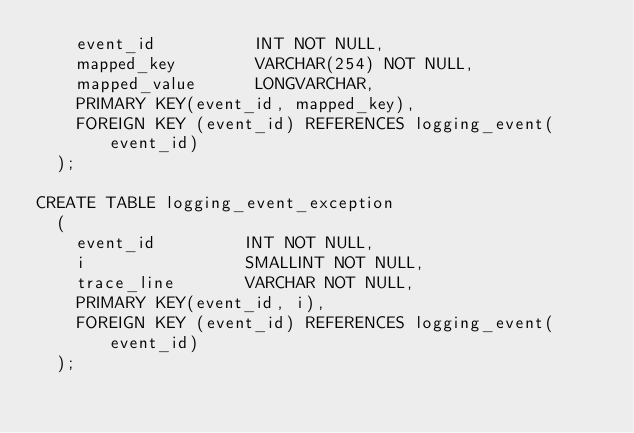<code> <loc_0><loc_0><loc_500><loc_500><_SQL_>    event_id	      INT NOT NULL,
    mapped_key        VARCHAR(254) NOT NULL,
    mapped_value      LONGVARCHAR,
    PRIMARY KEY(event_id, mapped_key),
    FOREIGN KEY (event_id) REFERENCES logging_event(event_id)
  );

CREATE TABLE logging_event_exception
  (
    event_id         INT NOT NULL,
    i                SMALLINT NOT NULL,
    trace_line       VARCHAR NOT NULL,
    PRIMARY KEY(event_id, i),
    FOREIGN KEY (event_id) REFERENCES logging_event(event_id)
  );
</code> 